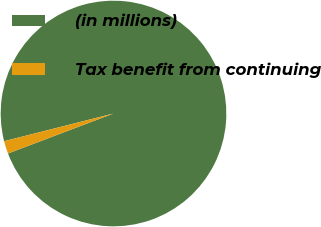Convert chart. <chart><loc_0><loc_0><loc_500><loc_500><pie_chart><fcel>(in millions)<fcel>Tax benefit from continuing<nl><fcel>98.18%<fcel>1.82%<nl></chart> 